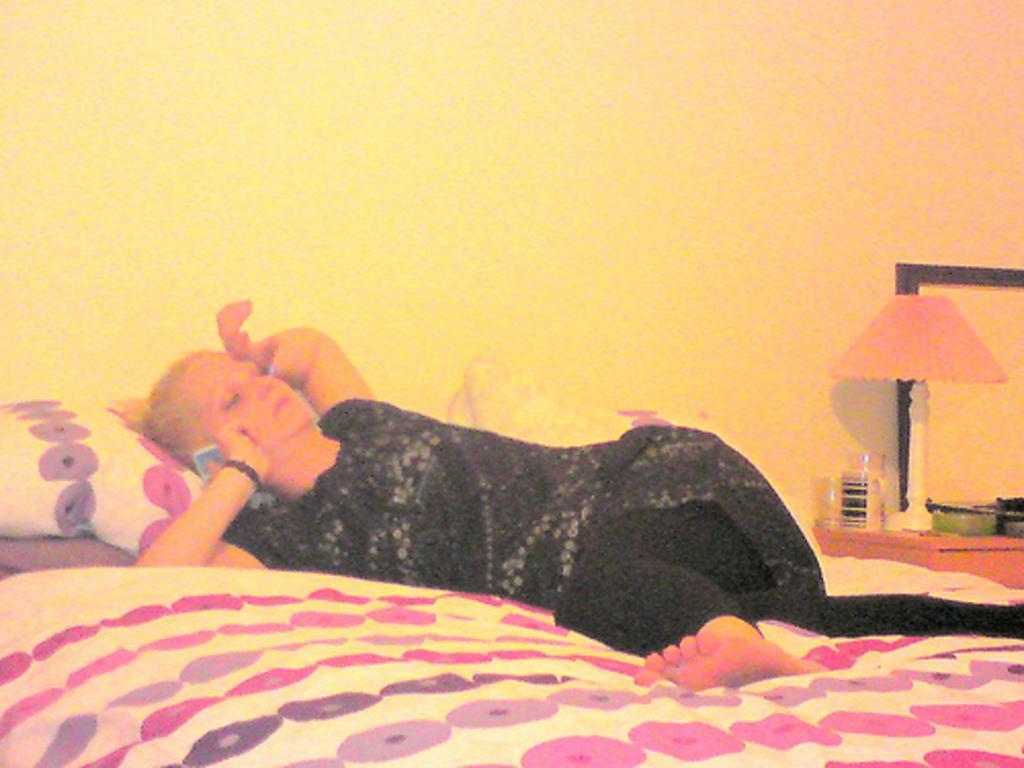Please provide a concise description of this image. In this image in the center there is a woman laying on the bed. On the right side there is a lamp on the table and there are glasses and there is an object which is green in colour. 